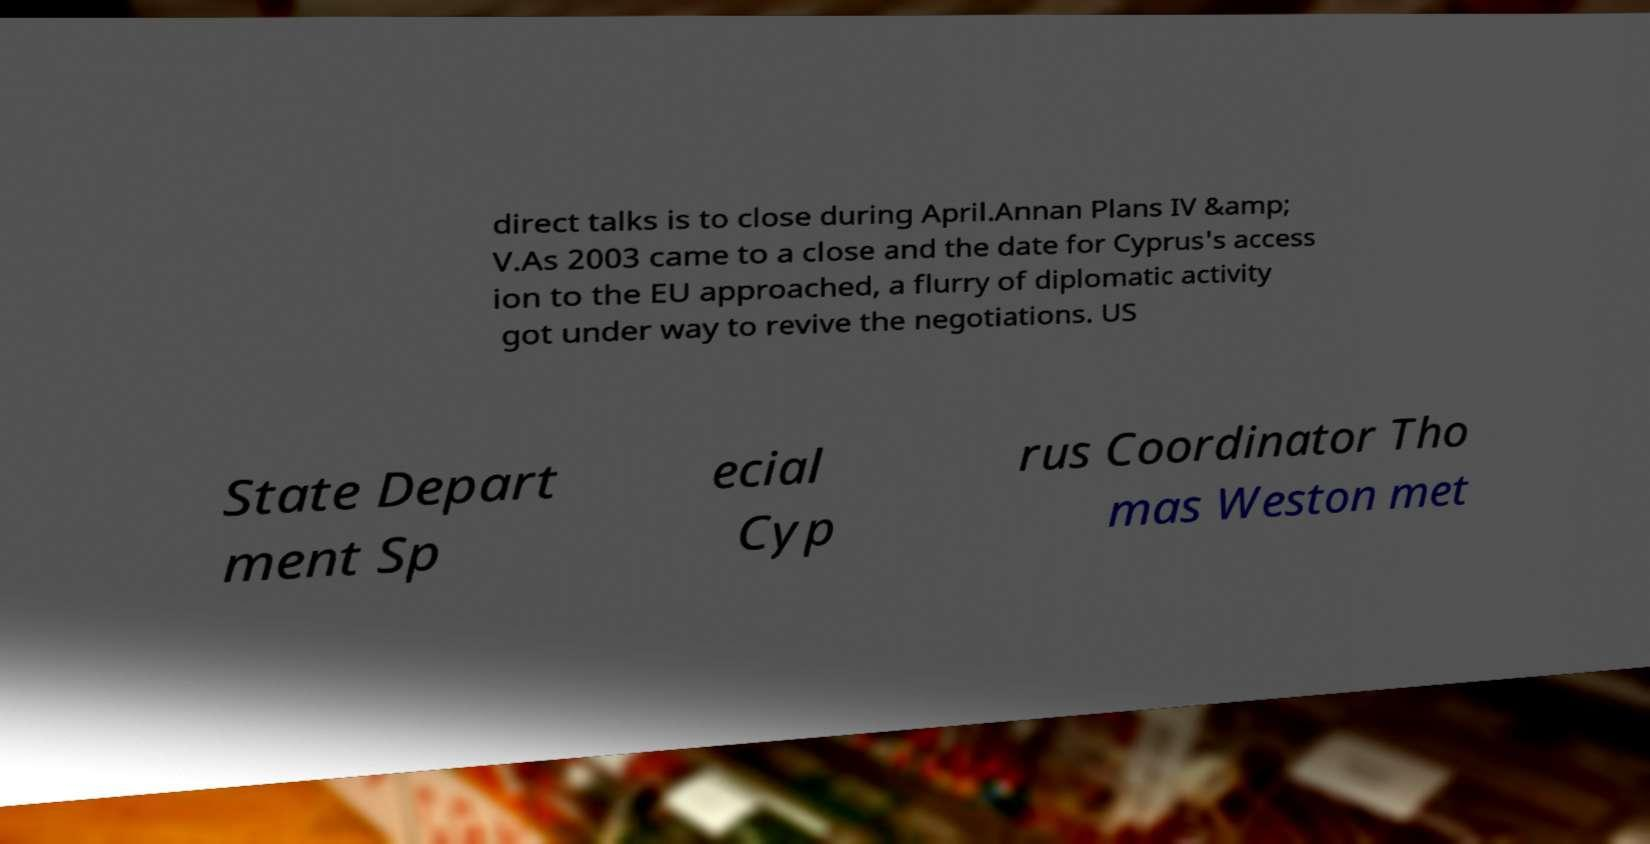What messages or text are displayed in this image? I need them in a readable, typed format. direct talks is to close during April.Annan Plans IV &amp; V.As 2003 came to a close and the date for Cyprus's access ion to the EU approached, a flurry of diplomatic activity got under way to revive the negotiations. US State Depart ment Sp ecial Cyp rus Coordinator Tho mas Weston met 